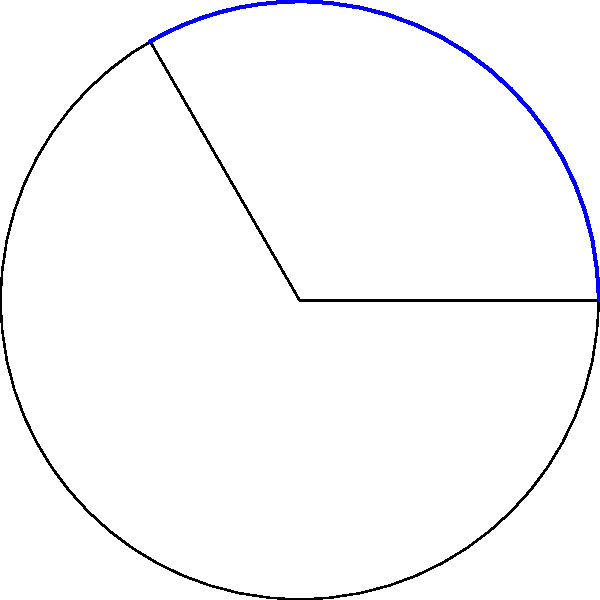As you take a break from your writing project, you find yourself pondering over a geometry problem inspired by the professor's recent lecture. A circular sector has a central angle of 120° and a radius of 5 cm. What is the area of this sector? Let's approach this step-by-step:

1) The formula for the area of a circular sector is:

   $$A = \frac{\theta}{360°} \pi r^2$$

   where $A$ is the area, $\theta$ is the central angle in degrees, and $r$ is the radius.

2) We're given:
   - Central angle $\theta = 120°$
   - Radius $r = 5$ cm

3) Let's substitute these values into our formula:

   $$A = \frac{120°}{360°} \pi (5\text{ cm})^2$$

4) Simplify the fraction:

   $$A = \frac{1}{3} \pi (25\text{ cm}^2)$$

5) Multiply:

   $$A = \frac{25\pi}{3} \text{ cm}^2$$

6) If we need a numerical value, we can use $\pi \approx 3.14159$:

   $$A \approx \frac{25 \times 3.14159}{3} \text{ cm}^2 \approx 26.18 \text{ cm}^2$$

Thus, the area of the circular sector is $\frac{25\pi}{3}$ square centimeters, or approximately 26.18 square centimeters.
Answer: $\frac{25\pi}{3}$ cm² 